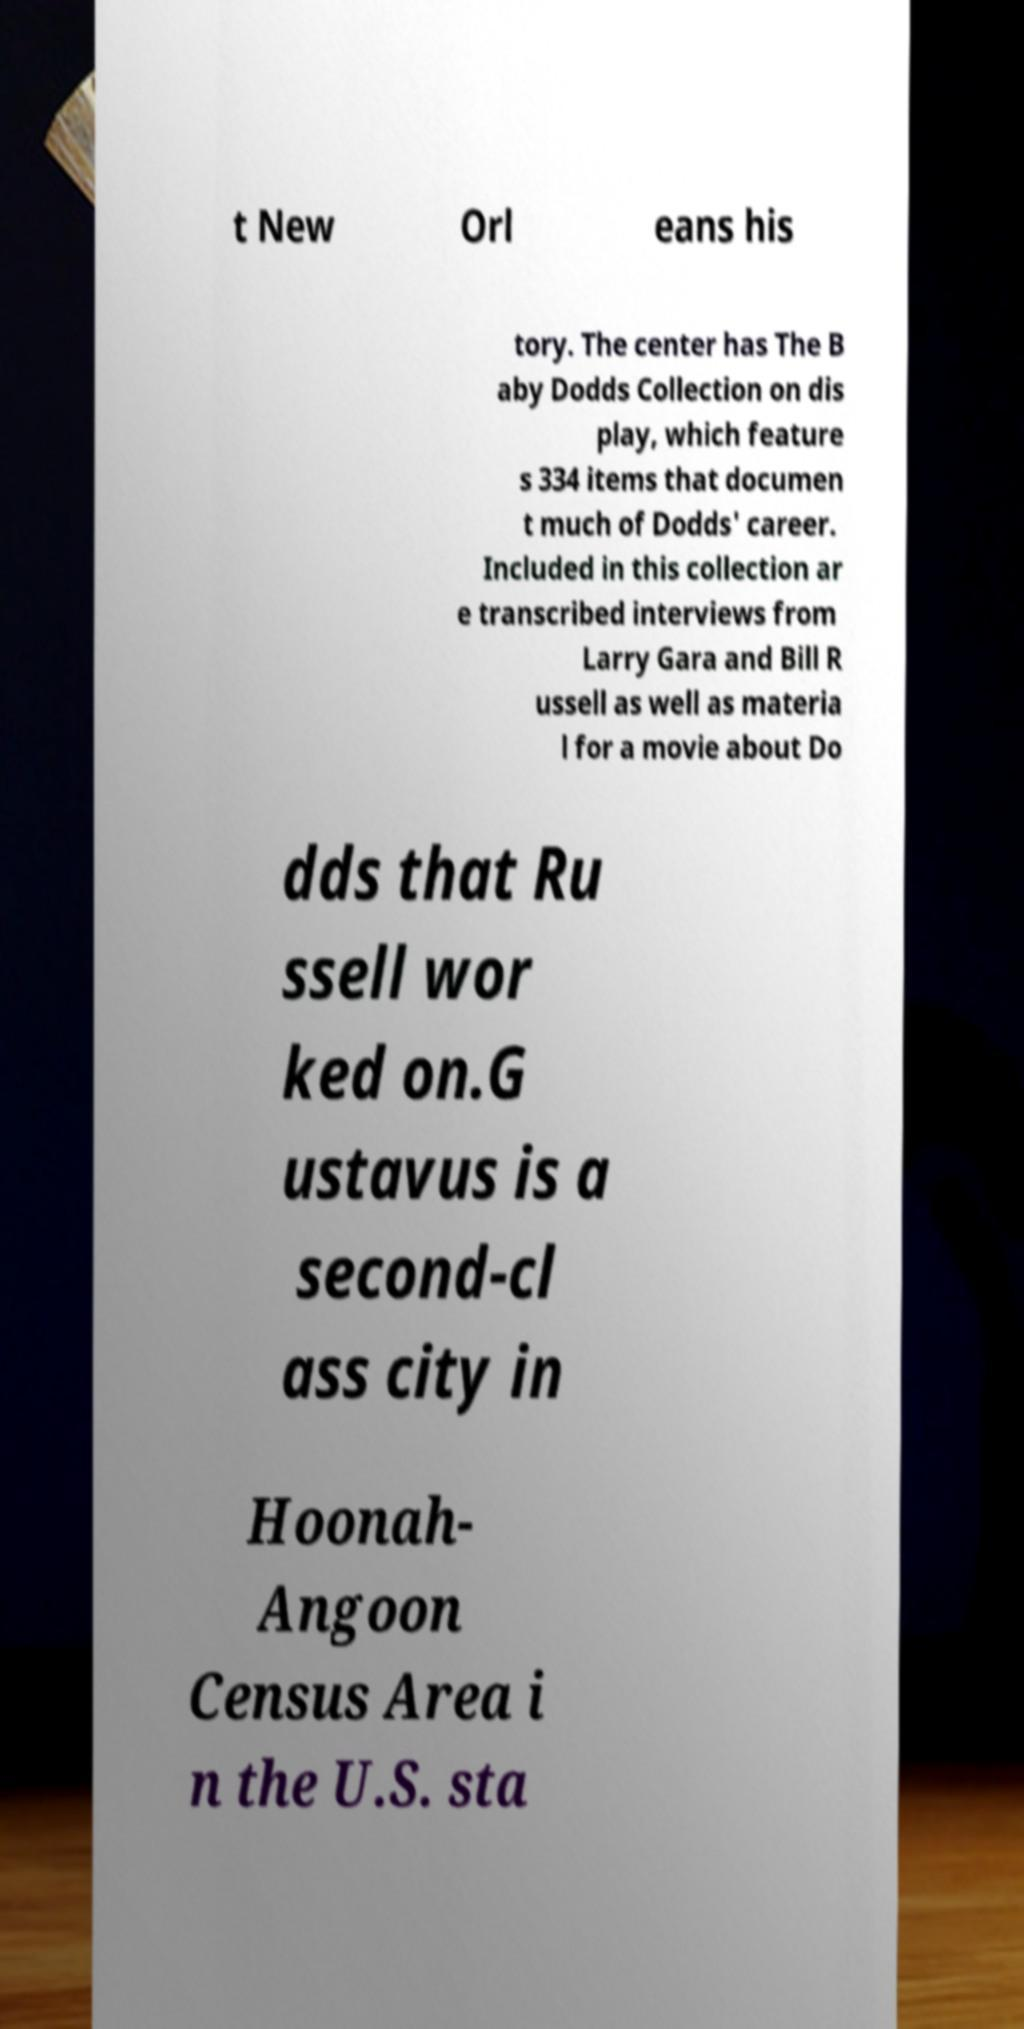Can you read and provide the text displayed in the image?This photo seems to have some interesting text. Can you extract and type it out for me? t New Orl eans his tory. The center has The B aby Dodds Collection on dis play, which feature s 334 items that documen t much of Dodds' career. Included in this collection ar e transcribed interviews from Larry Gara and Bill R ussell as well as materia l for a movie about Do dds that Ru ssell wor ked on.G ustavus is a second-cl ass city in Hoonah- Angoon Census Area i n the U.S. sta 